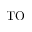Convert formula to latex. <formula><loc_0><loc_0><loc_500><loc_500>T O</formula> 